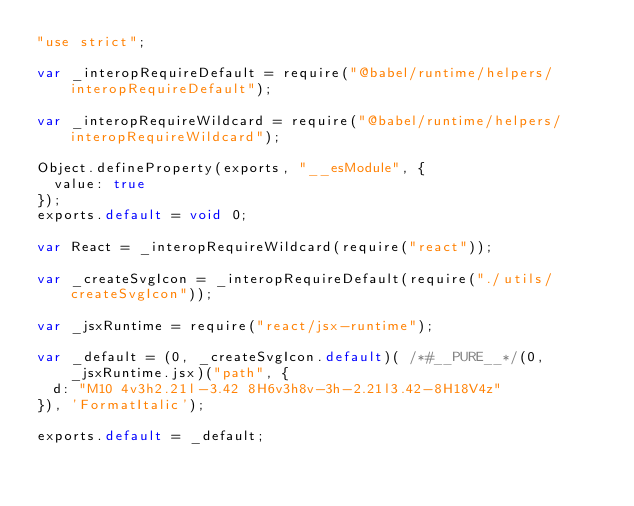<code> <loc_0><loc_0><loc_500><loc_500><_JavaScript_>"use strict";

var _interopRequireDefault = require("@babel/runtime/helpers/interopRequireDefault");

var _interopRequireWildcard = require("@babel/runtime/helpers/interopRequireWildcard");

Object.defineProperty(exports, "__esModule", {
  value: true
});
exports.default = void 0;

var React = _interopRequireWildcard(require("react"));

var _createSvgIcon = _interopRequireDefault(require("./utils/createSvgIcon"));

var _jsxRuntime = require("react/jsx-runtime");

var _default = (0, _createSvgIcon.default)( /*#__PURE__*/(0, _jsxRuntime.jsx)("path", {
  d: "M10 4v3h2.21l-3.42 8H6v3h8v-3h-2.21l3.42-8H18V4z"
}), 'FormatItalic');

exports.default = _default;</code> 